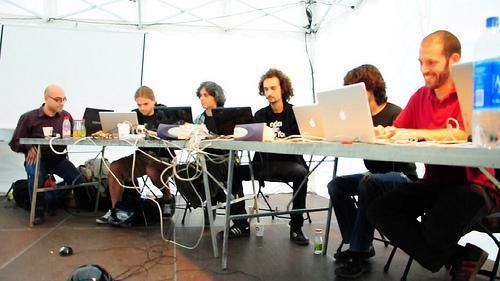How many apple laptops are on the table?
Give a very brief answer. 3. 